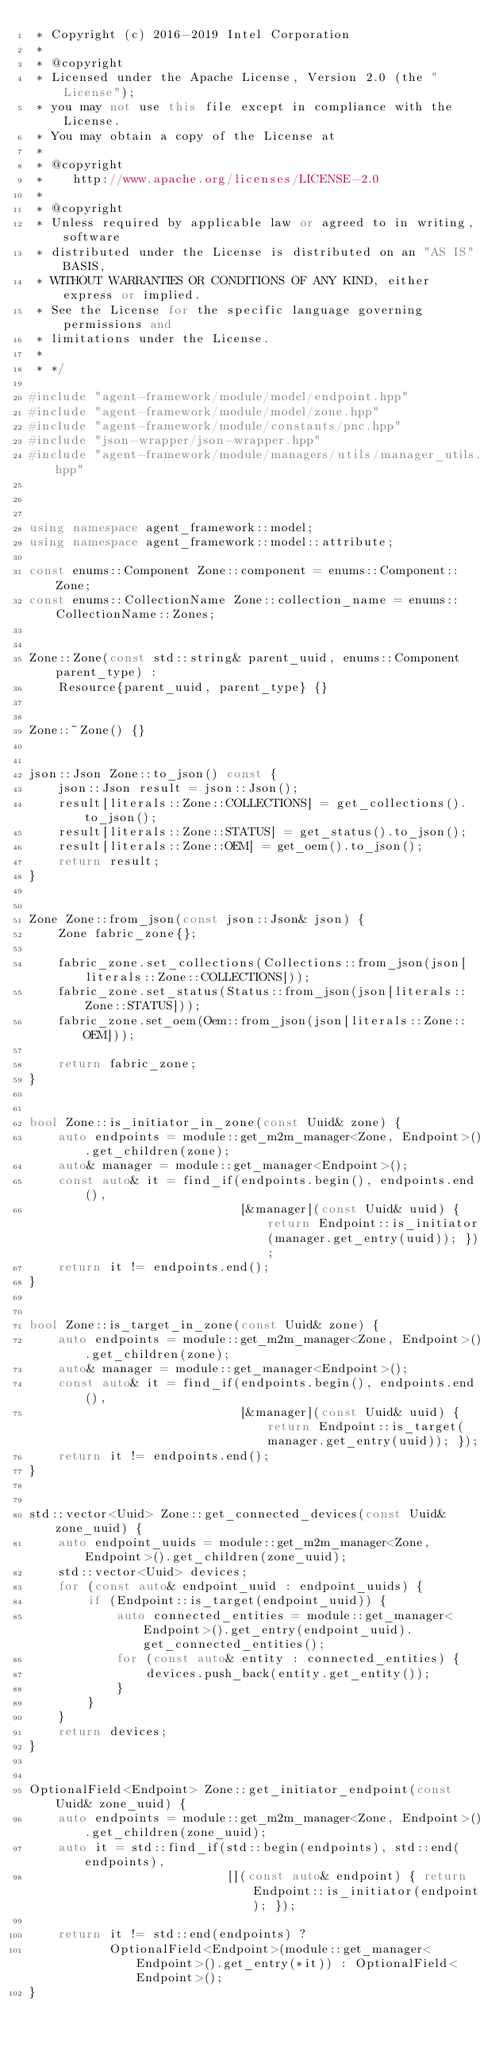Convert code to text. <code><loc_0><loc_0><loc_500><loc_500><_C++_> * Copyright (c) 2016-2019 Intel Corporation
 *
 * @copyright
 * Licensed under the Apache License, Version 2.0 (the "License");
 * you may not use this file except in compliance with the License.
 * You may obtain a copy of the License at
 *
 * @copyright
 *    http://www.apache.org/licenses/LICENSE-2.0
 *
 * @copyright
 * Unless required by applicable law or agreed to in writing, software
 * distributed under the License is distributed on an "AS IS" BASIS,
 * WITHOUT WARRANTIES OR CONDITIONS OF ANY KIND, either express or implied.
 * See the License for the specific language governing permissions and
 * limitations under the License.
 *
 * */

#include "agent-framework/module/model/endpoint.hpp"
#include "agent-framework/module/model/zone.hpp"
#include "agent-framework/module/constants/pnc.hpp"
#include "json-wrapper/json-wrapper.hpp"
#include "agent-framework/module/managers/utils/manager_utils.hpp"



using namespace agent_framework::model;
using namespace agent_framework::model::attribute;

const enums::Component Zone::component = enums::Component::Zone;
const enums::CollectionName Zone::collection_name = enums::CollectionName::Zones;


Zone::Zone(const std::string& parent_uuid, enums::Component parent_type) :
    Resource{parent_uuid, parent_type} {}


Zone::~Zone() {}


json::Json Zone::to_json() const {
    json::Json result = json::Json();
    result[literals::Zone::COLLECTIONS] = get_collections().to_json();
    result[literals::Zone::STATUS] = get_status().to_json();
    result[literals::Zone::OEM] = get_oem().to_json();
    return result;
}


Zone Zone::from_json(const json::Json& json) {
    Zone fabric_zone{};

    fabric_zone.set_collections(Collections::from_json(json[literals::Zone::COLLECTIONS]));
    fabric_zone.set_status(Status::from_json(json[literals::Zone::STATUS]));
    fabric_zone.set_oem(Oem::from_json(json[literals::Zone::OEM]));

    return fabric_zone;
}


bool Zone::is_initiator_in_zone(const Uuid& zone) {
    auto endpoints = module::get_m2m_manager<Zone, Endpoint>().get_children(zone);
    auto& manager = module::get_manager<Endpoint>();
    const auto& it = find_if(endpoints.begin(), endpoints.end(),
                             [&manager](const Uuid& uuid) { return Endpoint::is_initiator(manager.get_entry(uuid)); });
    return it != endpoints.end();
}


bool Zone::is_target_in_zone(const Uuid& zone) {
    auto endpoints = module::get_m2m_manager<Zone, Endpoint>().get_children(zone);
    auto& manager = module::get_manager<Endpoint>();
    const auto& it = find_if(endpoints.begin(), endpoints.end(),
                             [&manager](const Uuid& uuid) { return Endpoint::is_target(manager.get_entry(uuid)); });
    return it != endpoints.end();
}


std::vector<Uuid> Zone::get_connected_devices(const Uuid& zone_uuid) {
    auto endpoint_uuids = module::get_m2m_manager<Zone, Endpoint>().get_children(zone_uuid);
    std::vector<Uuid> devices;
    for (const auto& endpoint_uuid : endpoint_uuids) {
        if (Endpoint::is_target(endpoint_uuid)) {
            auto connected_entities = module::get_manager<Endpoint>().get_entry(endpoint_uuid).get_connected_entities();
            for (const auto& entity : connected_entities) {
                devices.push_back(entity.get_entity());
            }
        }
    }
    return devices;
}


OptionalField<Endpoint> Zone::get_initiator_endpoint(const Uuid& zone_uuid) {
    auto endpoints = module::get_m2m_manager<Zone, Endpoint>().get_children(zone_uuid);
    auto it = std::find_if(std::begin(endpoints), std::end(endpoints),
                           [](const auto& endpoint) { return Endpoint::is_initiator(endpoint); });

    return it != std::end(endpoints) ?
           OptionalField<Endpoint>(module::get_manager<Endpoint>().get_entry(*it)) : OptionalField<Endpoint>();
}</code> 